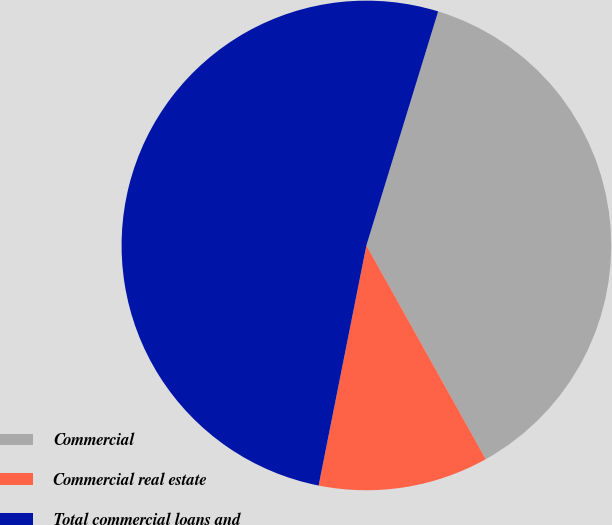<chart> <loc_0><loc_0><loc_500><loc_500><pie_chart><fcel>Commercial<fcel>Commercial real estate<fcel>Total commercial loans and<nl><fcel>37.16%<fcel>11.23%<fcel>51.61%<nl></chart> 